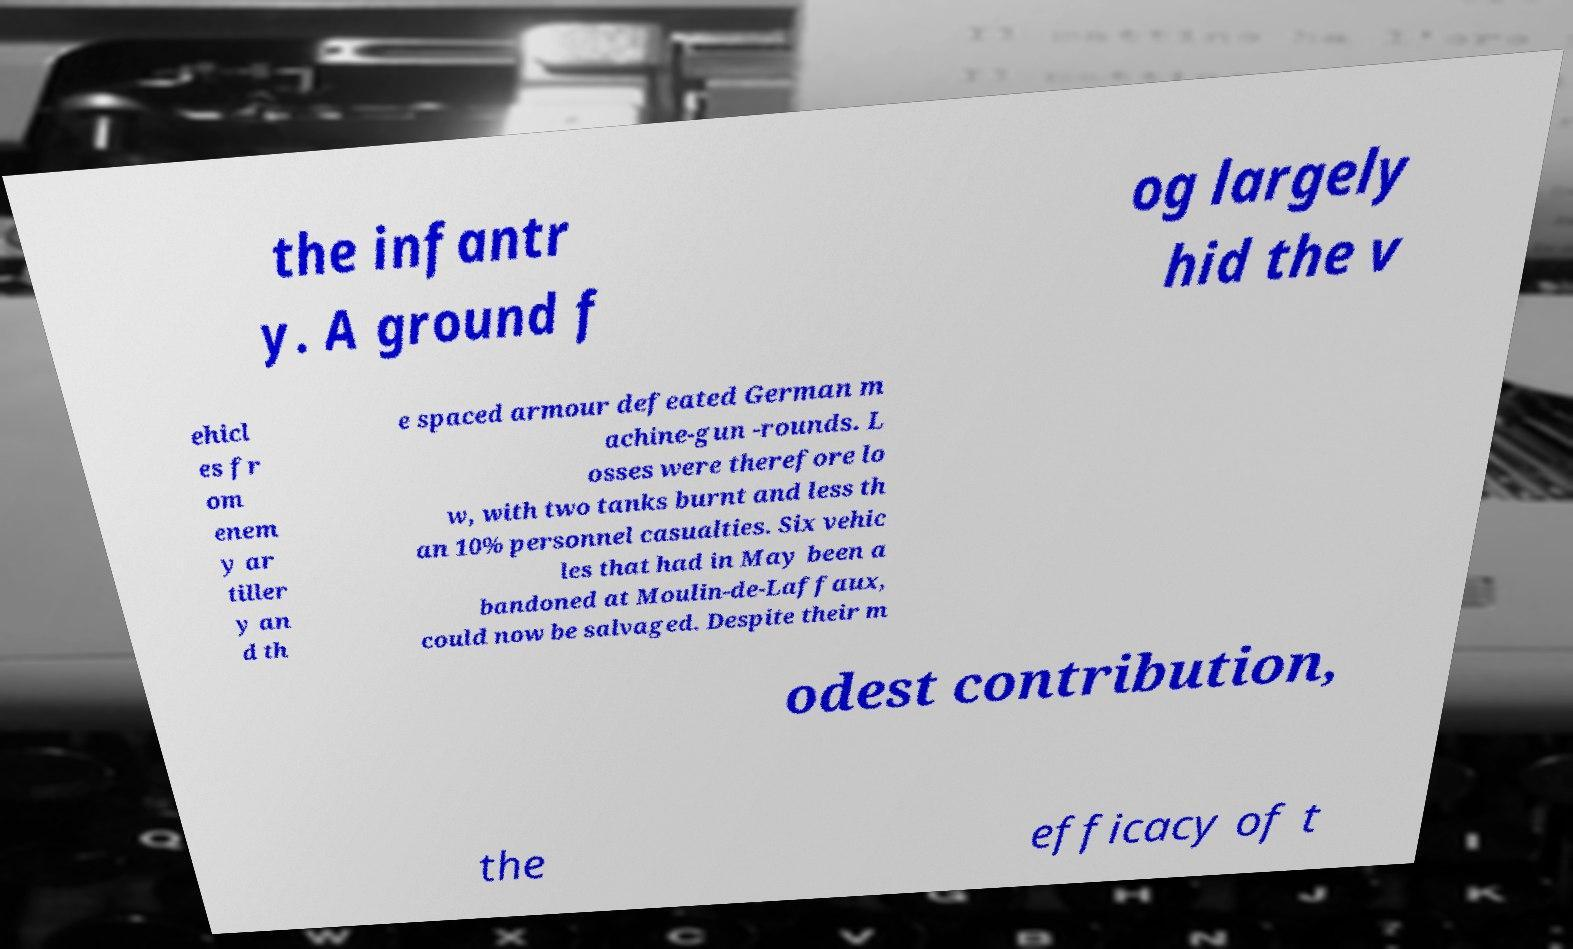Can you read and provide the text displayed in the image?This photo seems to have some interesting text. Can you extract and type it out for me? the infantr y. A ground f og largely hid the v ehicl es fr om enem y ar tiller y an d th e spaced armour defeated German m achine-gun -rounds. L osses were therefore lo w, with two tanks burnt and less th an 10% personnel casualties. Six vehic les that had in May been a bandoned at Moulin-de-Laffaux, could now be salvaged. Despite their m odest contribution, the efficacy of t 